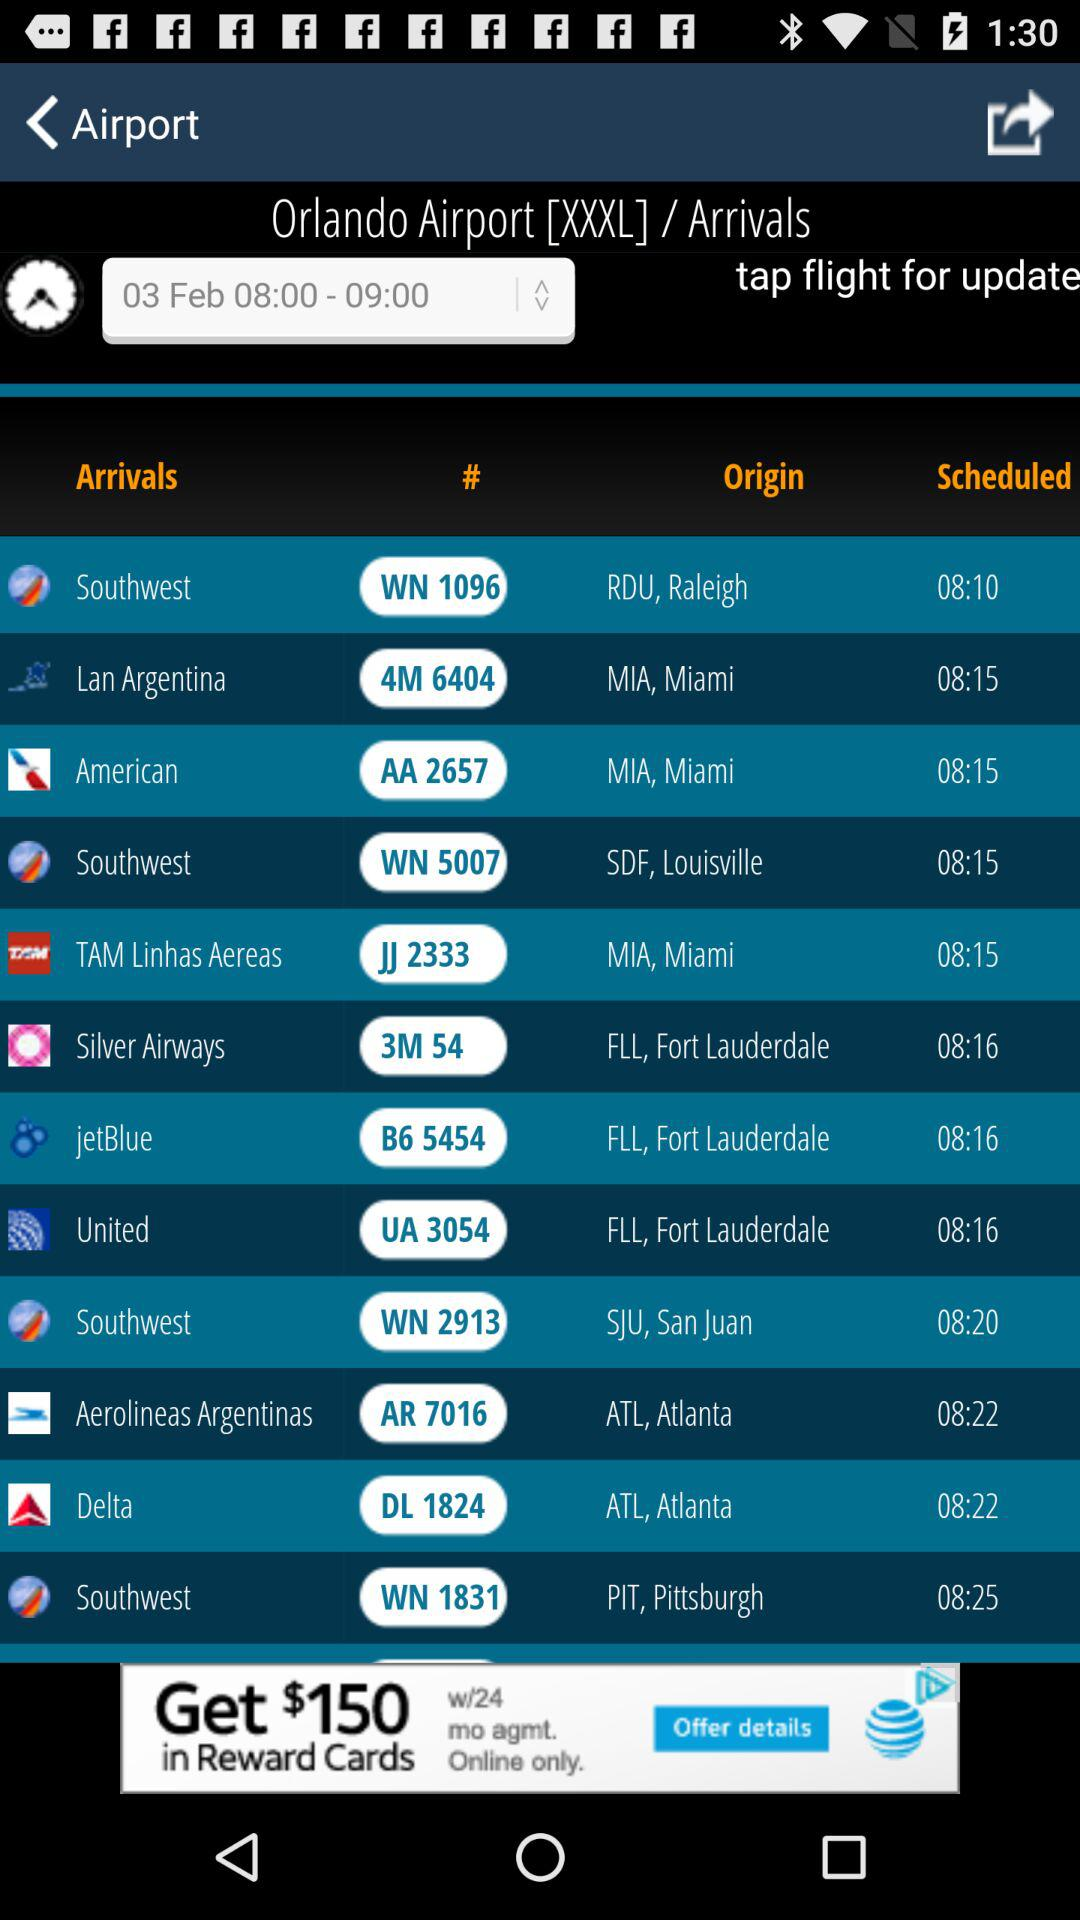What is the time for South West flight arrivals? The time for South West flight arrivals is 08:10. 